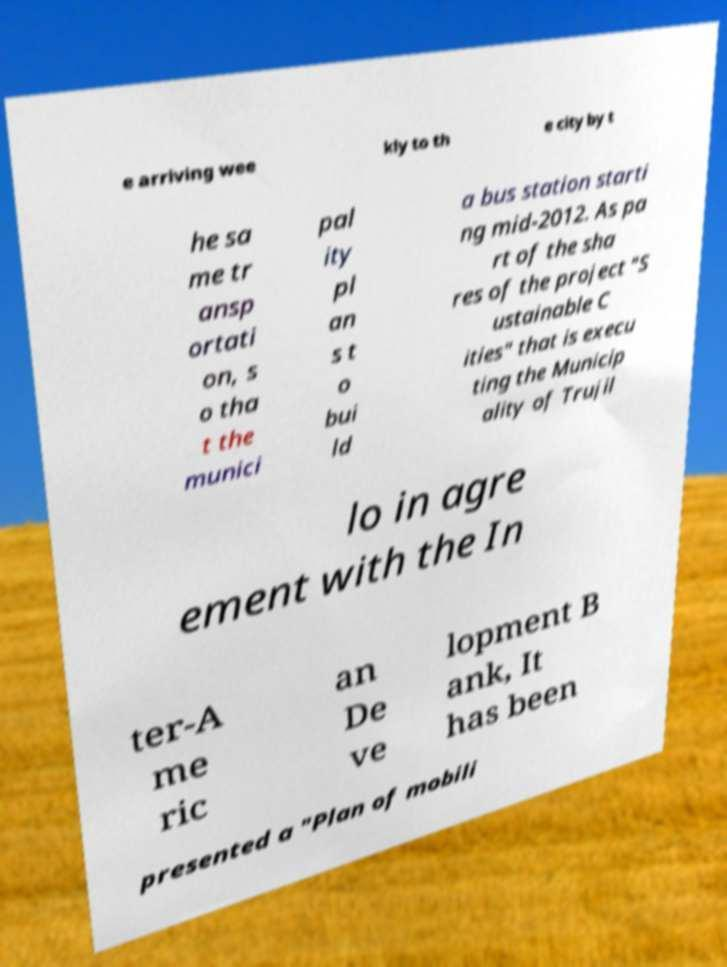Can you read and provide the text displayed in the image?This photo seems to have some interesting text. Can you extract and type it out for me? e arriving wee kly to th e city by t he sa me tr ansp ortati on, s o tha t the munici pal ity pl an s t o bui ld a bus station starti ng mid-2012. As pa rt of the sha res of the project "S ustainable C ities" that is execu ting the Municip ality of Trujil lo in agre ement with the In ter-A me ric an De ve lopment B ank, It has been presented a "Plan of mobili 